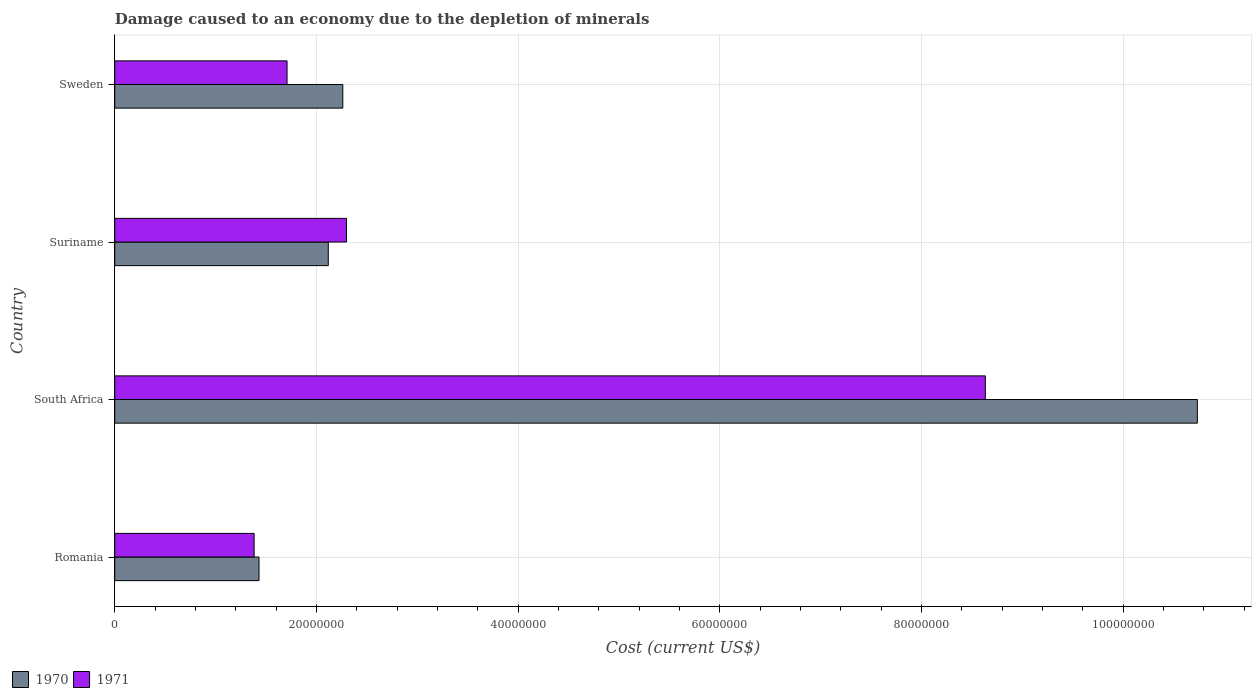How many bars are there on the 2nd tick from the top?
Ensure brevity in your answer.  2. How many bars are there on the 1st tick from the bottom?
Provide a short and direct response. 2. What is the label of the 4th group of bars from the top?
Provide a succinct answer. Romania. In how many cases, is the number of bars for a given country not equal to the number of legend labels?
Ensure brevity in your answer.  0. What is the cost of damage caused due to the depletion of minerals in 1971 in South Africa?
Ensure brevity in your answer.  8.63e+07. Across all countries, what is the maximum cost of damage caused due to the depletion of minerals in 1971?
Your answer should be compact. 8.63e+07. Across all countries, what is the minimum cost of damage caused due to the depletion of minerals in 1970?
Give a very brief answer. 1.43e+07. In which country was the cost of damage caused due to the depletion of minerals in 1970 maximum?
Your response must be concise. South Africa. In which country was the cost of damage caused due to the depletion of minerals in 1971 minimum?
Your answer should be compact. Romania. What is the total cost of damage caused due to the depletion of minerals in 1970 in the graph?
Offer a terse response. 1.65e+08. What is the difference between the cost of damage caused due to the depletion of minerals in 1970 in South Africa and that in Sweden?
Keep it short and to the point. 8.47e+07. What is the difference between the cost of damage caused due to the depletion of minerals in 1970 in Suriname and the cost of damage caused due to the depletion of minerals in 1971 in Sweden?
Your response must be concise. 4.09e+06. What is the average cost of damage caused due to the depletion of minerals in 1971 per country?
Make the answer very short. 3.51e+07. What is the difference between the cost of damage caused due to the depletion of minerals in 1970 and cost of damage caused due to the depletion of minerals in 1971 in Suriname?
Provide a succinct answer. -1.81e+06. In how many countries, is the cost of damage caused due to the depletion of minerals in 1970 greater than 104000000 US$?
Your answer should be very brief. 1. What is the ratio of the cost of damage caused due to the depletion of minerals in 1970 in Romania to that in Sweden?
Provide a short and direct response. 0.63. Is the difference between the cost of damage caused due to the depletion of minerals in 1970 in South Africa and Sweden greater than the difference between the cost of damage caused due to the depletion of minerals in 1971 in South Africa and Sweden?
Provide a short and direct response. Yes. What is the difference between the highest and the second highest cost of damage caused due to the depletion of minerals in 1970?
Give a very brief answer. 8.47e+07. What is the difference between the highest and the lowest cost of damage caused due to the depletion of minerals in 1971?
Your answer should be very brief. 7.25e+07. In how many countries, is the cost of damage caused due to the depletion of minerals in 1971 greater than the average cost of damage caused due to the depletion of minerals in 1971 taken over all countries?
Provide a short and direct response. 1. Is the sum of the cost of damage caused due to the depletion of minerals in 1971 in Romania and South Africa greater than the maximum cost of damage caused due to the depletion of minerals in 1970 across all countries?
Offer a very short reply. No. What does the 1st bar from the top in Romania represents?
Provide a short and direct response. 1971. What does the 1st bar from the bottom in Sweden represents?
Offer a very short reply. 1970. Are all the bars in the graph horizontal?
Give a very brief answer. Yes. How many countries are there in the graph?
Keep it short and to the point. 4. Does the graph contain grids?
Give a very brief answer. Yes. What is the title of the graph?
Ensure brevity in your answer.  Damage caused to an economy due to the depletion of minerals. Does "1986" appear as one of the legend labels in the graph?
Your answer should be compact. No. What is the label or title of the X-axis?
Offer a very short reply. Cost (current US$). What is the Cost (current US$) of 1970 in Romania?
Keep it short and to the point. 1.43e+07. What is the Cost (current US$) in 1971 in Romania?
Ensure brevity in your answer.  1.38e+07. What is the Cost (current US$) of 1970 in South Africa?
Your response must be concise. 1.07e+08. What is the Cost (current US$) of 1971 in South Africa?
Make the answer very short. 8.63e+07. What is the Cost (current US$) in 1970 in Suriname?
Your answer should be very brief. 2.12e+07. What is the Cost (current US$) in 1971 in Suriname?
Your answer should be very brief. 2.30e+07. What is the Cost (current US$) in 1970 in Sweden?
Give a very brief answer. 2.26e+07. What is the Cost (current US$) in 1971 in Sweden?
Provide a short and direct response. 1.71e+07. Across all countries, what is the maximum Cost (current US$) of 1970?
Give a very brief answer. 1.07e+08. Across all countries, what is the maximum Cost (current US$) of 1971?
Offer a very short reply. 8.63e+07. Across all countries, what is the minimum Cost (current US$) of 1970?
Provide a short and direct response. 1.43e+07. Across all countries, what is the minimum Cost (current US$) of 1971?
Your response must be concise. 1.38e+07. What is the total Cost (current US$) in 1970 in the graph?
Offer a very short reply. 1.65e+08. What is the total Cost (current US$) of 1971 in the graph?
Your response must be concise. 1.40e+08. What is the difference between the Cost (current US$) of 1970 in Romania and that in South Africa?
Offer a terse response. -9.31e+07. What is the difference between the Cost (current US$) in 1971 in Romania and that in South Africa?
Provide a short and direct response. -7.25e+07. What is the difference between the Cost (current US$) in 1970 in Romania and that in Suriname?
Your response must be concise. -6.87e+06. What is the difference between the Cost (current US$) of 1971 in Romania and that in Suriname?
Offer a very short reply. -9.16e+06. What is the difference between the Cost (current US$) in 1970 in Romania and that in Sweden?
Provide a short and direct response. -8.31e+06. What is the difference between the Cost (current US$) of 1971 in Romania and that in Sweden?
Give a very brief answer. -3.26e+06. What is the difference between the Cost (current US$) in 1970 in South Africa and that in Suriname?
Make the answer very short. 8.62e+07. What is the difference between the Cost (current US$) of 1971 in South Africa and that in Suriname?
Keep it short and to the point. 6.33e+07. What is the difference between the Cost (current US$) of 1970 in South Africa and that in Sweden?
Your response must be concise. 8.47e+07. What is the difference between the Cost (current US$) of 1971 in South Africa and that in Sweden?
Provide a succinct answer. 6.92e+07. What is the difference between the Cost (current US$) in 1970 in Suriname and that in Sweden?
Keep it short and to the point. -1.44e+06. What is the difference between the Cost (current US$) in 1971 in Suriname and that in Sweden?
Offer a very short reply. 5.90e+06. What is the difference between the Cost (current US$) of 1970 in Romania and the Cost (current US$) of 1971 in South Africa?
Provide a short and direct response. -7.20e+07. What is the difference between the Cost (current US$) of 1970 in Romania and the Cost (current US$) of 1971 in Suriname?
Ensure brevity in your answer.  -8.68e+06. What is the difference between the Cost (current US$) of 1970 in Romania and the Cost (current US$) of 1971 in Sweden?
Give a very brief answer. -2.78e+06. What is the difference between the Cost (current US$) in 1970 in South Africa and the Cost (current US$) in 1971 in Suriname?
Make the answer very short. 8.44e+07. What is the difference between the Cost (current US$) in 1970 in South Africa and the Cost (current US$) in 1971 in Sweden?
Ensure brevity in your answer.  9.03e+07. What is the difference between the Cost (current US$) of 1970 in Suriname and the Cost (current US$) of 1971 in Sweden?
Offer a terse response. 4.09e+06. What is the average Cost (current US$) of 1970 per country?
Your answer should be compact. 4.14e+07. What is the average Cost (current US$) of 1971 per country?
Keep it short and to the point. 3.51e+07. What is the difference between the Cost (current US$) of 1970 and Cost (current US$) of 1971 in Romania?
Your answer should be compact. 4.85e+05. What is the difference between the Cost (current US$) in 1970 and Cost (current US$) in 1971 in South Africa?
Provide a succinct answer. 2.10e+07. What is the difference between the Cost (current US$) of 1970 and Cost (current US$) of 1971 in Suriname?
Offer a very short reply. -1.81e+06. What is the difference between the Cost (current US$) in 1970 and Cost (current US$) in 1971 in Sweden?
Make the answer very short. 5.53e+06. What is the ratio of the Cost (current US$) in 1970 in Romania to that in South Africa?
Your answer should be very brief. 0.13. What is the ratio of the Cost (current US$) in 1971 in Romania to that in South Africa?
Provide a short and direct response. 0.16. What is the ratio of the Cost (current US$) in 1970 in Romania to that in Suriname?
Provide a short and direct response. 0.68. What is the ratio of the Cost (current US$) in 1971 in Romania to that in Suriname?
Make the answer very short. 0.6. What is the ratio of the Cost (current US$) in 1970 in Romania to that in Sweden?
Your answer should be compact. 0.63. What is the ratio of the Cost (current US$) in 1971 in Romania to that in Sweden?
Offer a very short reply. 0.81. What is the ratio of the Cost (current US$) of 1970 in South Africa to that in Suriname?
Offer a very short reply. 5.07. What is the ratio of the Cost (current US$) in 1971 in South Africa to that in Suriname?
Your answer should be compact. 3.76. What is the ratio of the Cost (current US$) in 1970 in South Africa to that in Sweden?
Offer a very short reply. 4.75. What is the ratio of the Cost (current US$) of 1971 in South Africa to that in Sweden?
Your answer should be very brief. 5.05. What is the ratio of the Cost (current US$) of 1970 in Suriname to that in Sweden?
Your answer should be compact. 0.94. What is the ratio of the Cost (current US$) of 1971 in Suriname to that in Sweden?
Give a very brief answer. 1.35. What is the difference between the highest and the second highest Cost (current US$) in 1970?
Ensure brevity in your answer.  8.47e+07. What is the difference between the highest and the second highest Cost (current US$) of 1971?
Give a very brief answer. 6.33e+07. What is the difference between the highest and the lowest Cost (current US$) of 1970?
Keep it short and to the point. 9.31e+07. What is the difference between the highest and the lowest Cost (current US$) of 1971?
Keep it short and to the point. 7.25e+07. 